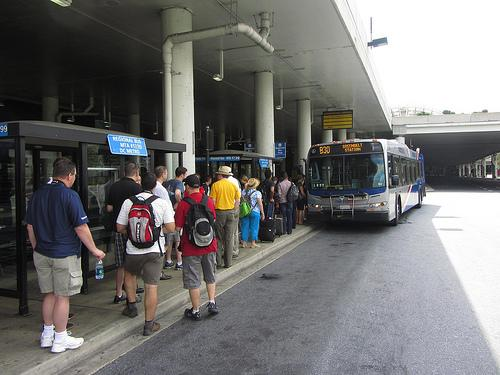Describe the scene related to the waiting people's interactions or activities. The people in the scene are waiting for the bus, with some wearing backpacks and standing in a line, likely preparing to board the bus. Mention the type of clothing various people are wearing and what objects they are carrying. People are wearing flannel shorts, a yellow shirt, blue pants, a red shirt, and green shorts. Some of them are also carrying backpacks. How many people can be identified in the image? Include people with specified clothing items. There are 15 identified people in the image, including those described by clothing items and those labeled as "this is a person." Identify the focal point of the image and explain the situation. The focal point is the line of people waiting to get on the bus at a transit station, indicating that it's a busy commuting hour. Enumerate the vehicles and their descriptions in the image. There are two vehicles: a gray and blue bus at the stop, and a blue-gray and white bus parked near the curb. What are the primary colors in the scene and which objects are associated with them? Primary colors in the scene are black, gray, red, yellow, and blue. Objects include a black hat, gray-red-black backpack, yellow shirt, blue pants, and blue-gray bus. What is the outdoor setting in this image, and what kind of service is provided at this location? This is an outside setting at a bus stop, with a transit station providing passenger bus service for the people. A green-shirted woman is holding an umbrella while waiting for the bus; try to find her. This instruction is misleading since there is no mention of a woman wearing a green shirt or holding an umbrella in the image information. Bringing up non-existent objects and people would confuse the viewer. Does the cat, roaming near the bus stop, appear to be searching for food? This instruction is misleading as there is no mention of a cat in the given image information. Asking about a cat, especially one that may be searching for food, would leave the viewer searching for something that does not exist in the image. Spot the bicycle leaning against the bus, with a blue helmet hanging on its handle. This instruction is misleading because the given image information does not mention anything about a bicycle or a blue helmet. Introducing these elements into the scene that don't actually exist would lead the viewer astray. Can you find the little girl wearing a pink dress near the bench? This instruction is misleading because there is no mention of a little girl, a pink dress, or a bench in the given image information. Thus, mentioning them as if they exist in the image would confuse the viewer. Notice how the elderly couple sits on the nearby bench, feeding the pigeons at their feet. This instruction is misleading since there is no mention of an elderly couple, a bench, or pigeons in the image information. Introducing such elements in the scene that don't actually exist would misguide and unnecessarily challenge the viewer. Observe the bus driver through the bus window, wearing sunglasses and a blue uniform. This instruction is misleading because there is no mention of the bus driver, sunglasses, or a blue uniform in the image information. Adding such details, which are not present in the image, would mislead the viewer. 